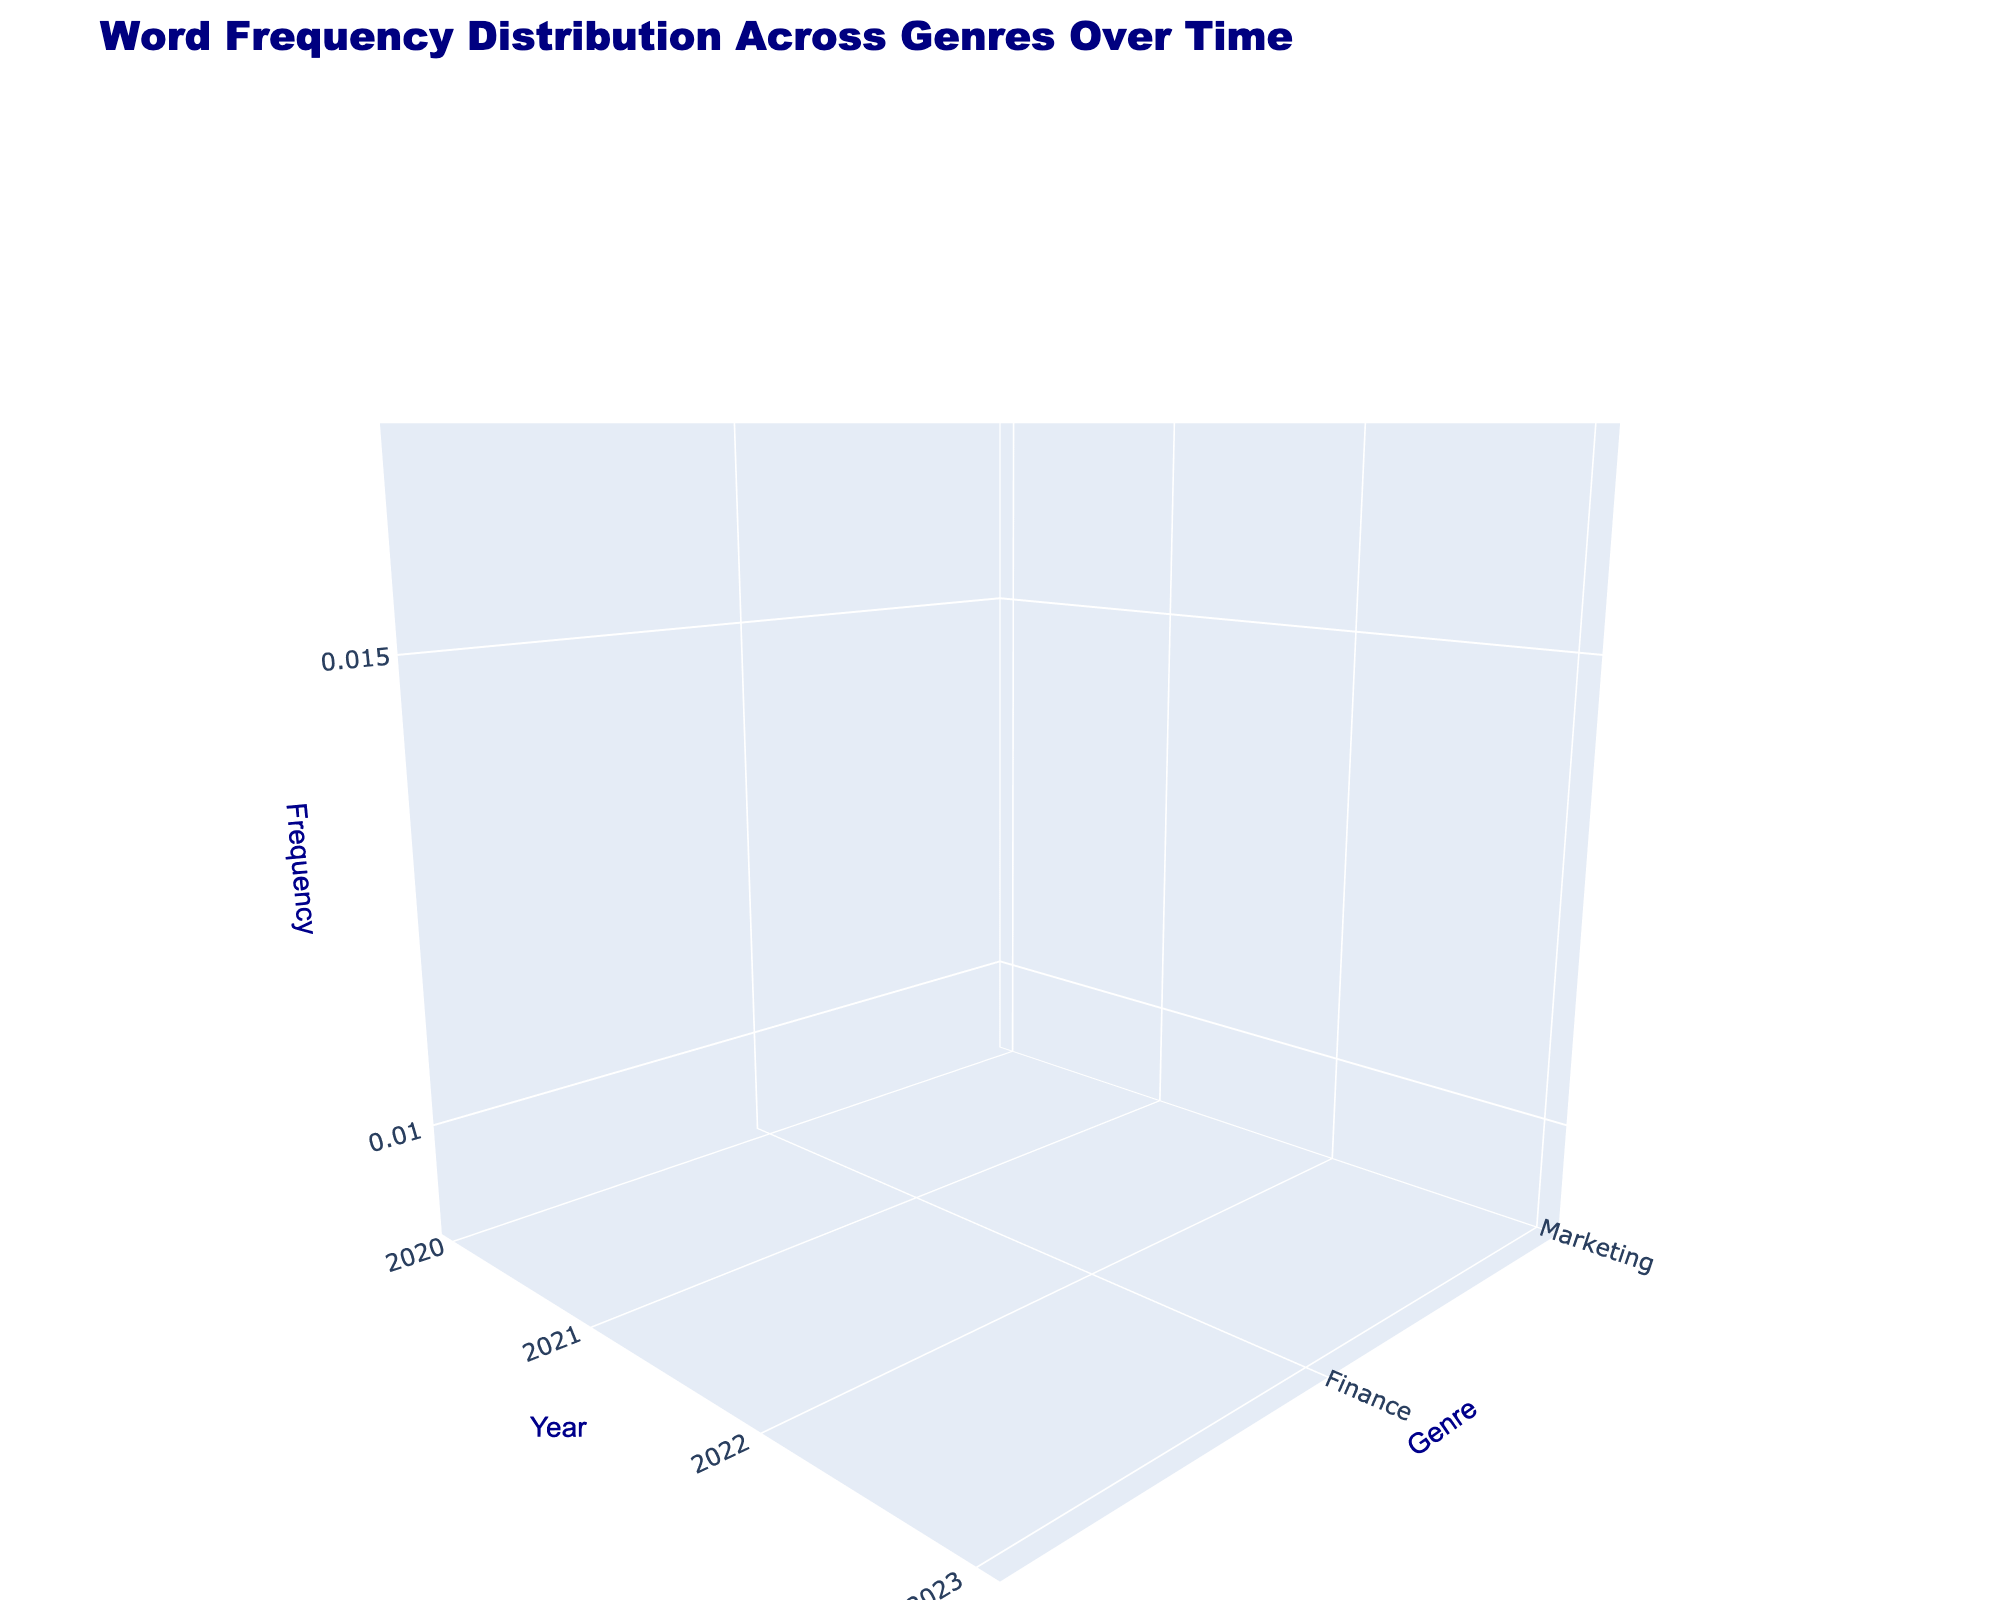What's the main title of the 3D surface plot? The main title of the plot is located at the top and typically describes the overall theme or subject of the visual representation. In this case, it is "Word Frequency Distribution Across Genres Over Time"
Answer: Word Frequency Distribution Across Genres Over Time What are the labels of the x, y, and z axes? The labels of the axes are typically provided to indicate what each dimension represents. For the x-axis (horizontal), it is "Year". For the y-axis (vertical), it is "Genre". For the z-axis (depth), it is "Frequency".
Answer: Year, Genre, Frequency Which word has the highest frequency in the year 2023 for the Tech genre? From the data points for the year 2023 in the Tech genre, the word with the highest z-axis value (frequency) should be identified. For Tech in 2023, the word "Innovation" has a frequency of 0.018, which is the highest.
Answer: Innovation How did the frequency of the word "AI" change from 2020 to 2023 in the Tech genre? To understand the change, compare the z-axis values (frequencies) for "AI" in the Tech genre from the years 2020 to 2023. In 2020, the frequency is 0.008; in 2021, it's 0.010; in 2022, it's 0.012; and in 2023, it's 0.014. This shows a consistent increase.
Answer: Increased Which genre shows the highest frequency for the word "Investment" in 2022? Check the z-axis values for the word "Investment" across all genres in 2022. The genre with the highest frequency for "Investment" in 2022 is Finance, with a frequency of 0.016.
Answer: Finance Are the frequencies of the word "Brand" in Marketing genre consistently increasing over the years? Analyze the frequencies of the word "Brand" in the Marketing genre from 2020 to 2023. The frequencies are: 2020 (0.013), 2021 (0.014), 2022 (0.015), 2023 (0.016). These values show a consistent increase every year.
Answer: Yes Which words are depicted in the 3D surface plot? The words used in the plot can be found by identifying the surfaces drawn in different colors. They are "Innovation," "Startup," "AI," "Investment," "Funding," "Venture," "Brand," "Growth," and "Strategy."
Answer: Innovation, Startup, AI, Investment, Funding, Venture, Brand, Growth, Strategy What can be inferred about the trend of word frequency for "Growth" in the Marketing genre from 2020 to 2023? By examining the z-axis values for "Growth" in the Marketing genre from 2020 (0.010), 2021 (0.011), 2022 (0.012), and 2023 (0.013), it can be inferred that the word "Growth" has a steadily increasing frequency over these years.
Answer: Increasing trend 